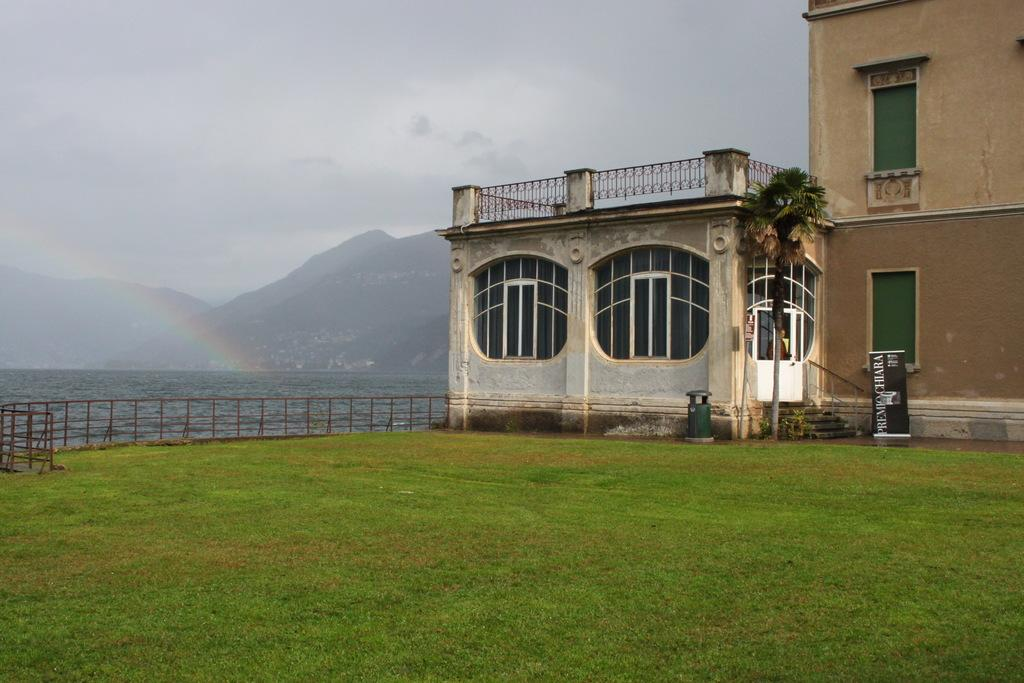What type of terrain is at the bottom of the image? There is grass at the bottom of the image. What can be seen in the distance in the image? There are mountains in the background of the image. What other structures are visible in the background of the image? There are buildings in the background of the image. What natural feature is visible in the background of the image? There is water visible in the background of the image. What is visible at the top of the image? The sky is visible at the top of the image. How many cents are visible in the image? There are no cents present in the image. What type of wish can be granted by the mountains in the image? There are no wishes or magical elements associated with the mountains in the image; they are simply a natural feature in the background. 